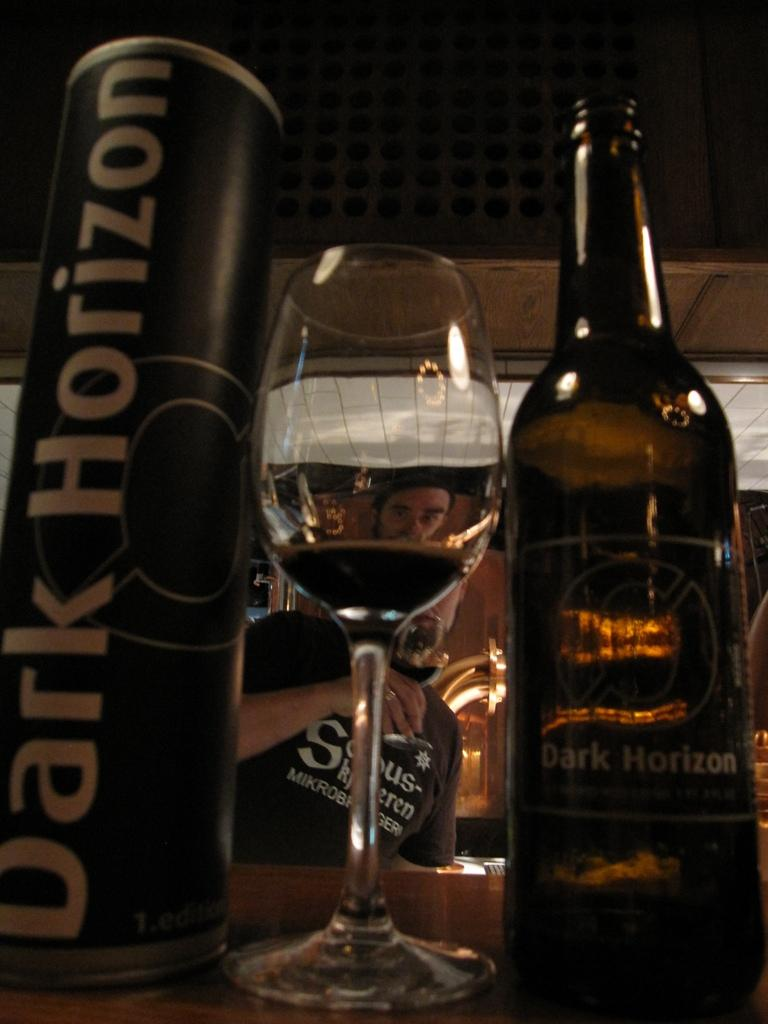What objects are on the table in the image? There is a bottle, a glass, and a tin on the table. What can be seen through the glass on the table? A person's face is visible through the glass. What is the person holding in the image? The person is holding a glass with a drink. What type of bells can be heard ringing in the image? There are no bells present in the image, and therefore no sound can be heard. Is there a string attached to the tin on the table? There is no mention of a string attached to the tin in the image. 